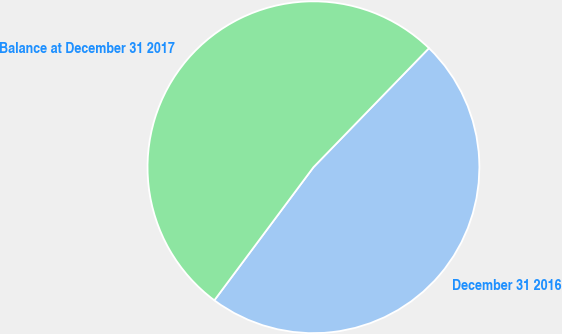<chart> <loc_0><loc_0><loc_500><loc_500><pie_chart><fcel>December 31 2016<fcel>Balance at December 31 2017<nl><fcel>47.93%<fcel>52.07%<nl></chart> 